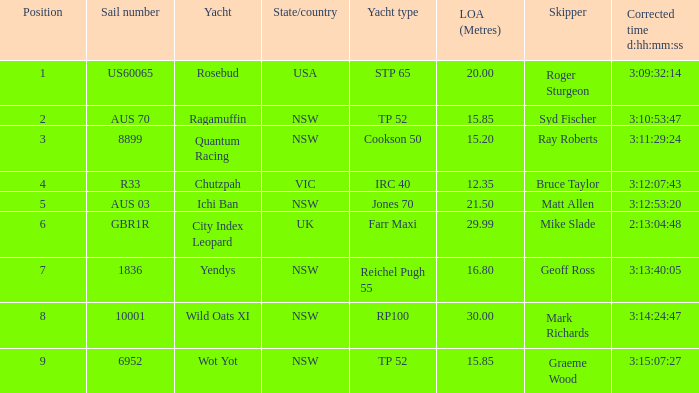How many yachts had a position of 3? 1.0. 